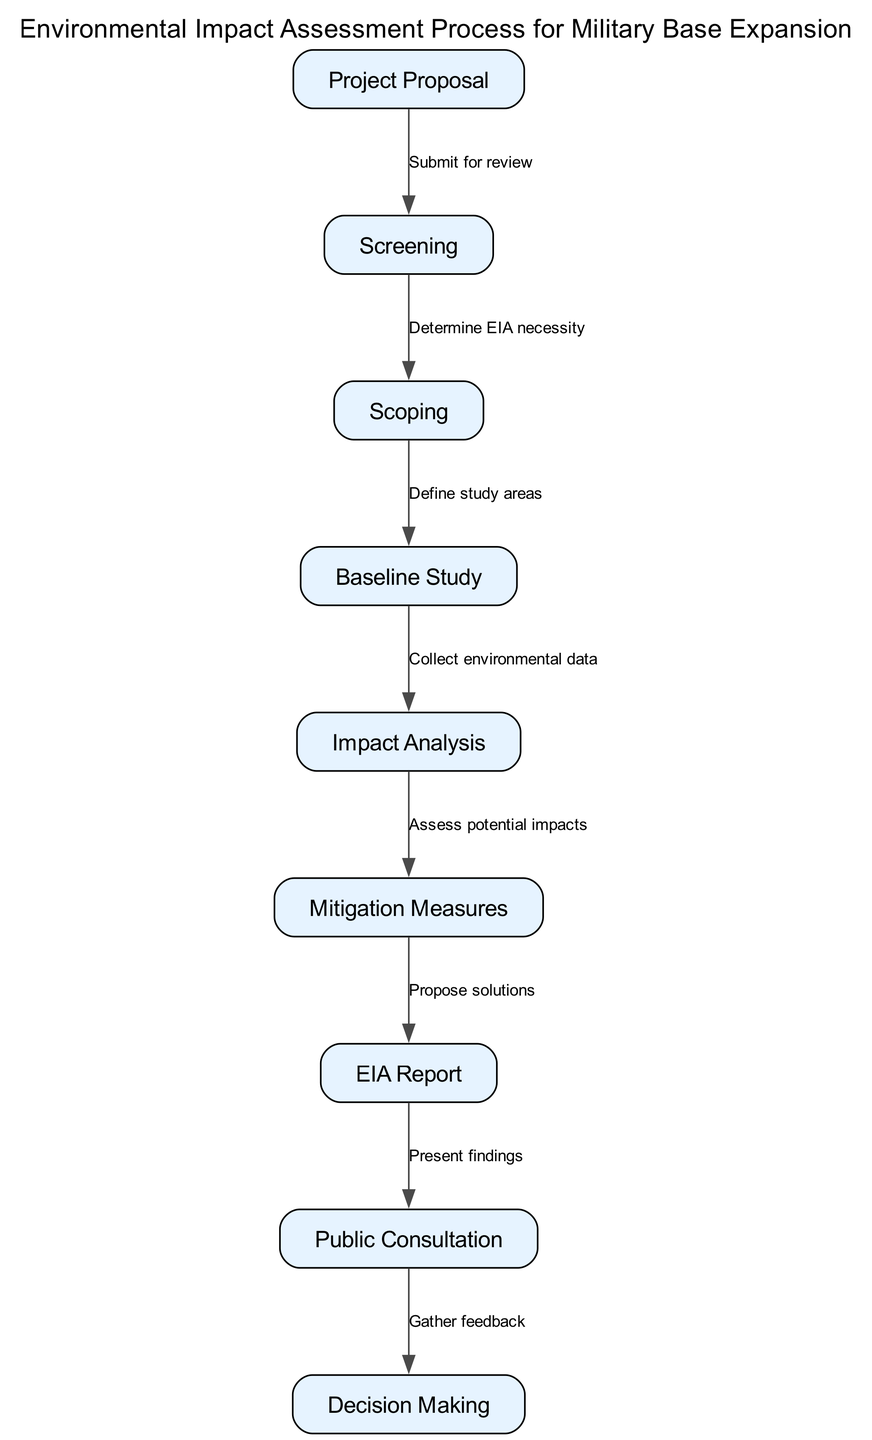What is the first step in the Environmental Impact Assessment process? The diagram indicates that the first step is the 'Project Proposal', which is the starting point of the assessment process.
Answer: Project Proposal How many nodes are there in the diagram? By counting the entries in the nodes section of the diagram, we find there are nine nodes that represent different steps in the assessment process.
Answer: Nine What action follows 'Baseline Study'? According to the diagram, 'Impact Analysis' follows 'Baseline Study', indicating the collection of environmental data leads directly to analyzing the potential impacts.
Answer: Impact Analysis What feedback mechanism is present in the diagram? The 'Public Consultation' step involves gathering feedback, which is represented as a direct connection from the 'EIA Report' node to the 'Decision Making' node.
Answer: Gather feedback What does 'Screening' determine? The 'Screening' node in the diagram determines the necessity of an Environmental Impact Assessment (EIA), as indicated by the connection to the 'Scoping' step.
Answer: EIA necessity Explain the relationship between 'EIA Report' and 'Public Consultation'. The diagram shows that the 'EIA Report' is completed before 'Public Consultation' occurs; thus, findings from the report are presented during this consultation phase, suggesting a flow of information.
Answer: Present findings Which step comes after 'Mitigation Measures'? Following 'Mitigation Measures', the next step indicated in the diagram is the 'EIA Report', which is created after proposing solutions to mitigate identified impacts.
Answer: EIA Report How does 'Impact Analysis' relate to 'Mitigation Measures'? The diagram illustrates that 'Impact Analysis' assesses potential impacts, which informs the development of 'Mitigation Measures' as a response to those impacts, indicating a logical progression from analysis to solution.
Answer: Assess potential impacts 